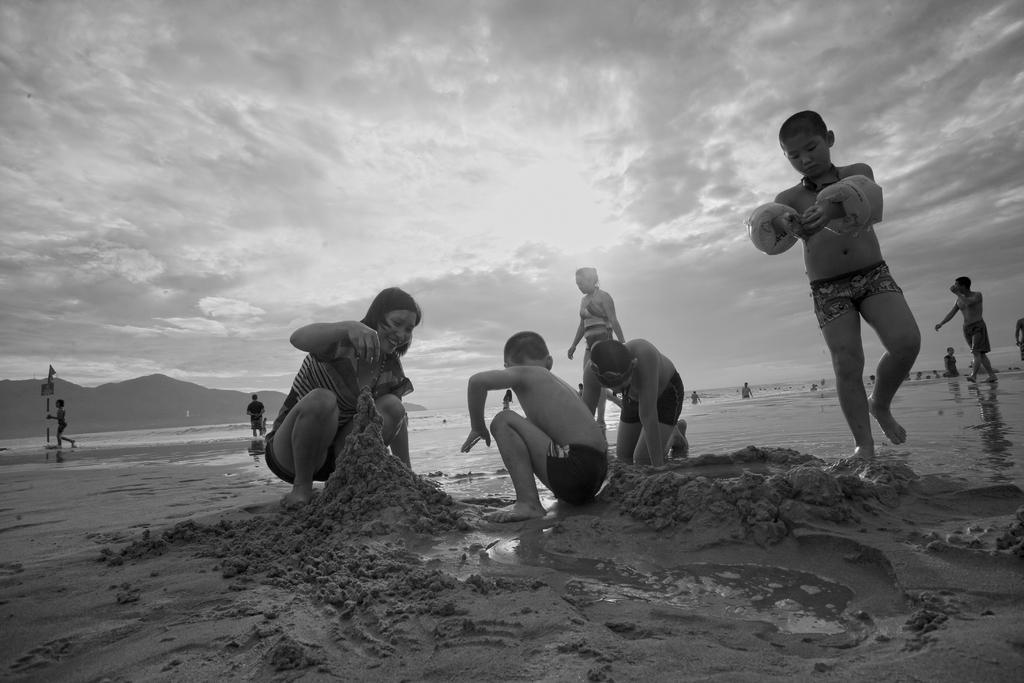In one or two sentences, can you explain what this image depicts? In this image I can see few people playing with the mud. There are other people at the back. There is water and mountains at the back. There are clouds in the sky and this is a black and white image. 